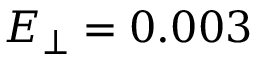<formula> <loc_0><loc_0><loc_500><loc_500>E _ { \perp } = 0 . 0 0 3</formula> 